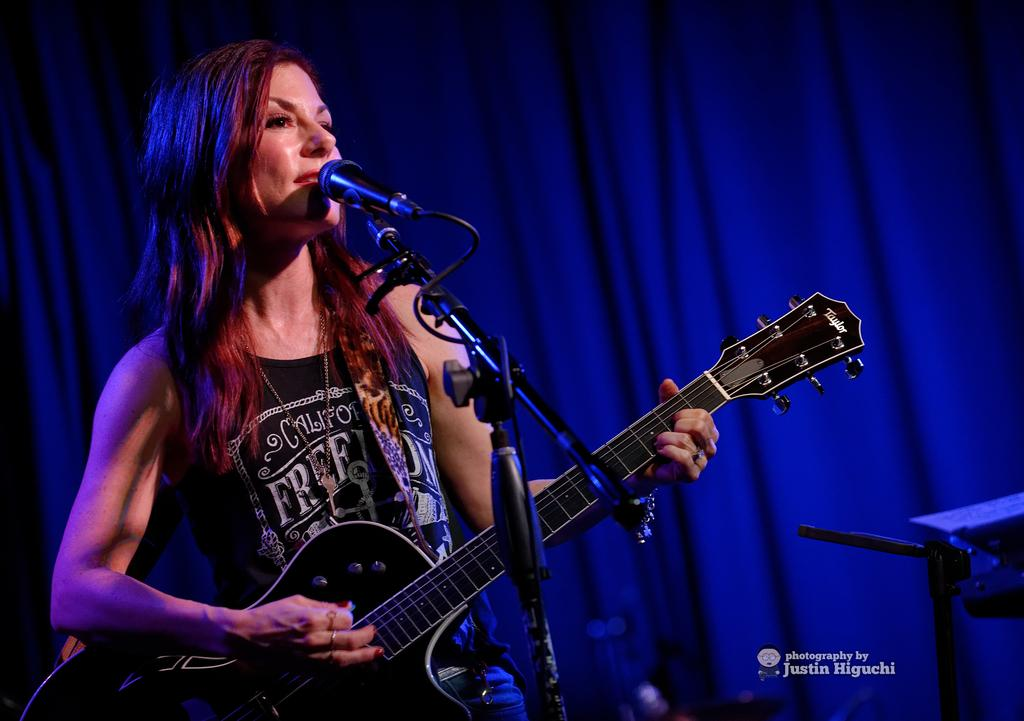Who is the main subject in the image? There is a woman in the image. What is the woman holding in the image? The woman is holding a guitar. What is the woman doing with the guitar? The woman is playing the guitar. What other equipment is present in the image? There is a microphone and a stand in the image. What can be seen in the background of the image? There is a curtain in the background of the image. Can you tell me how many donkeys are visible in the image? There are no donkeys present in the image. What type of plant is growing on the woman's chin in the image? There is no plant growing on the woman's chin in the image. 